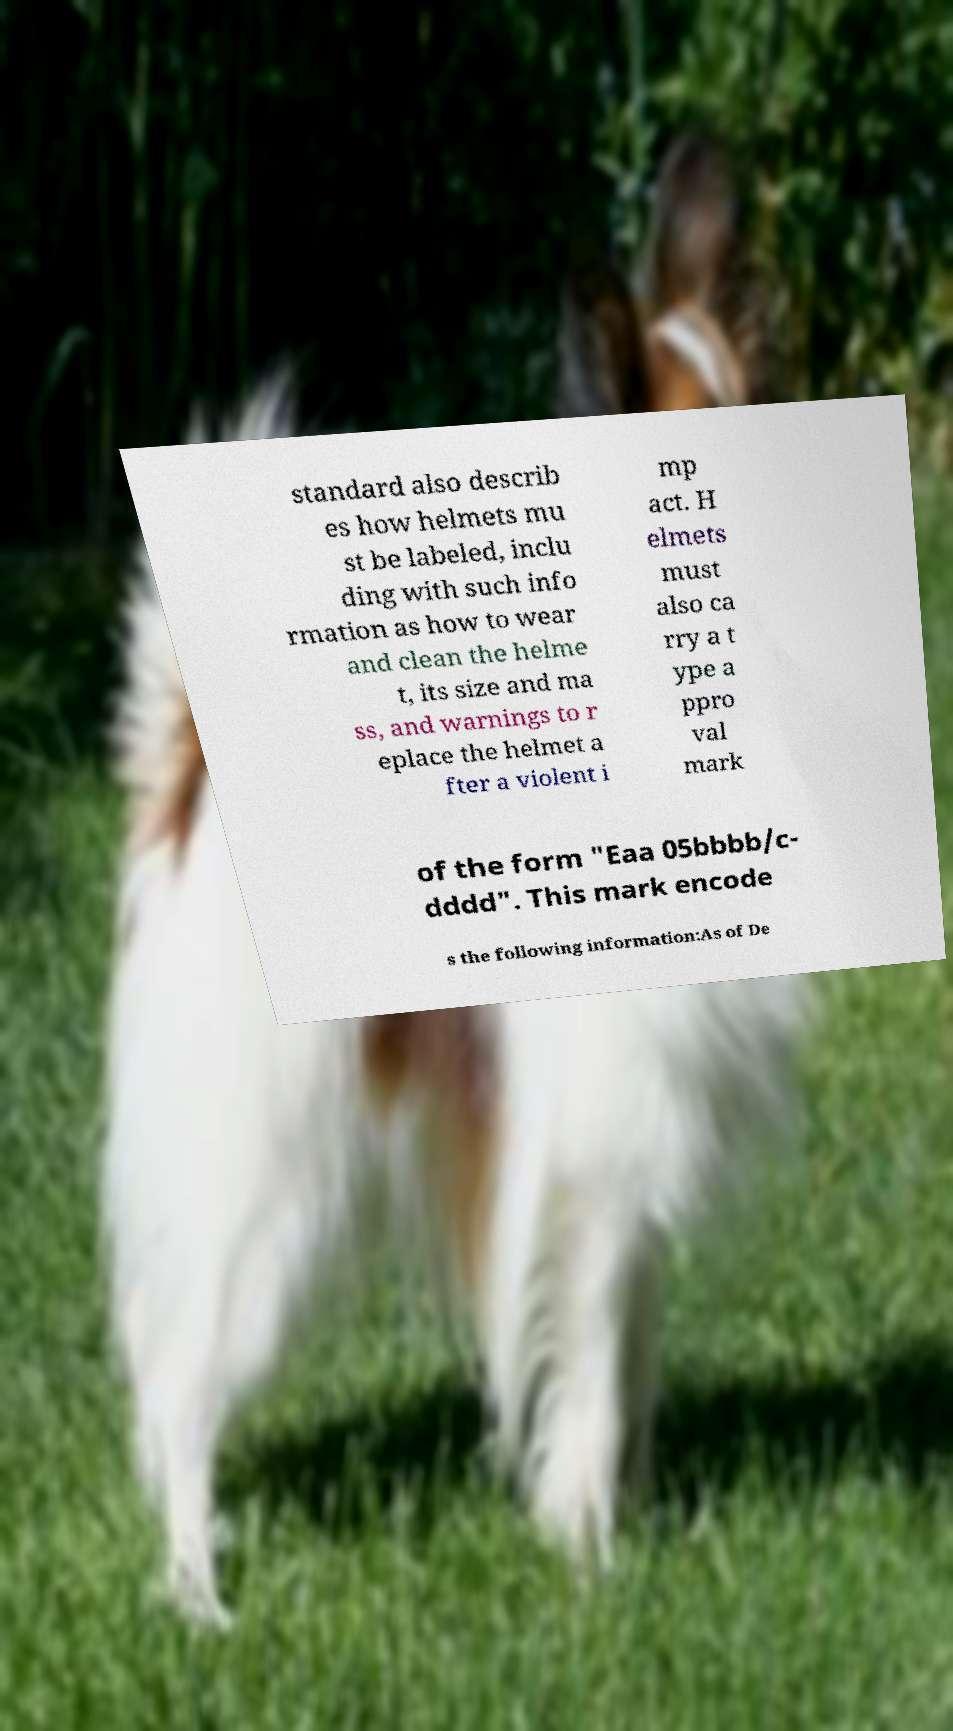Please read and relay the text visible in this image. What does it say? standard also describ es how helmets mu st be labeled, inclu ding with such info rmation as how to wear and clean the helme t, its size and ma ss, and warnings to r eplace the helmet a fter a violent i mp act. H elmets must also ca rry a t ype a ppro val mark of the form "Eaa 05bbbb/c- dddd". This mark encode s the following information:As of De 